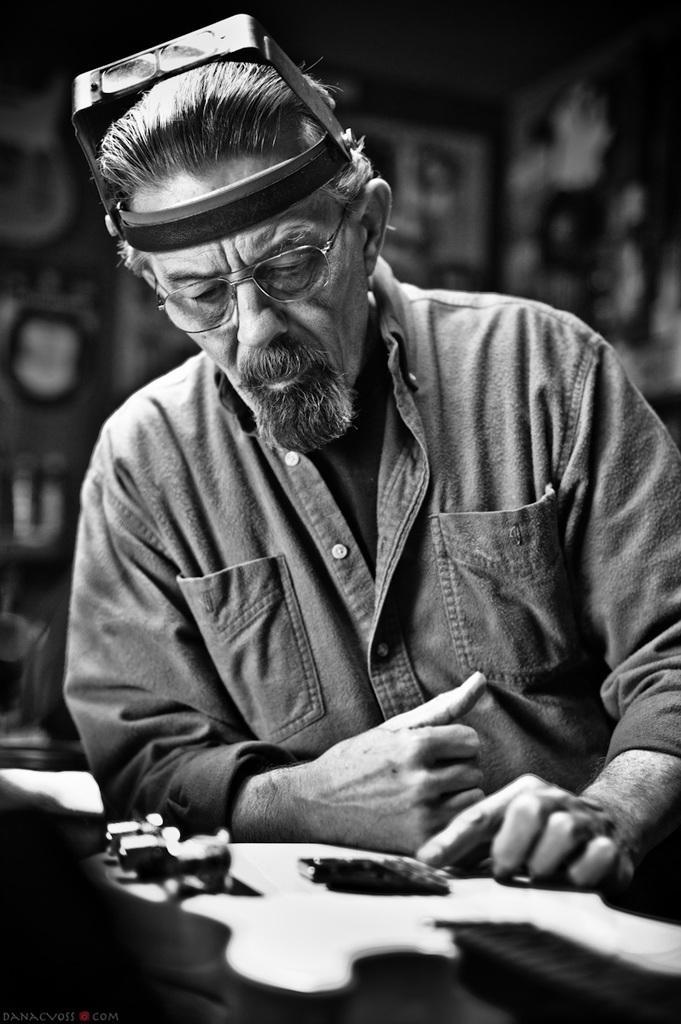Please provide a concise description of this image. Here in this picture we can see a man present over a place and in front of him we can see a table with somethings present and we can see he is wearing spectacles and watching the things and behind him we can see the background is in blurry manner. 